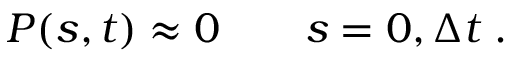Convert formula to latex. <formula><loc_0><loc_0><loc_500><loc_500>P ( s , t ) \approx 0 \quad s = 0 , { \Delta t } \, .</formula> 